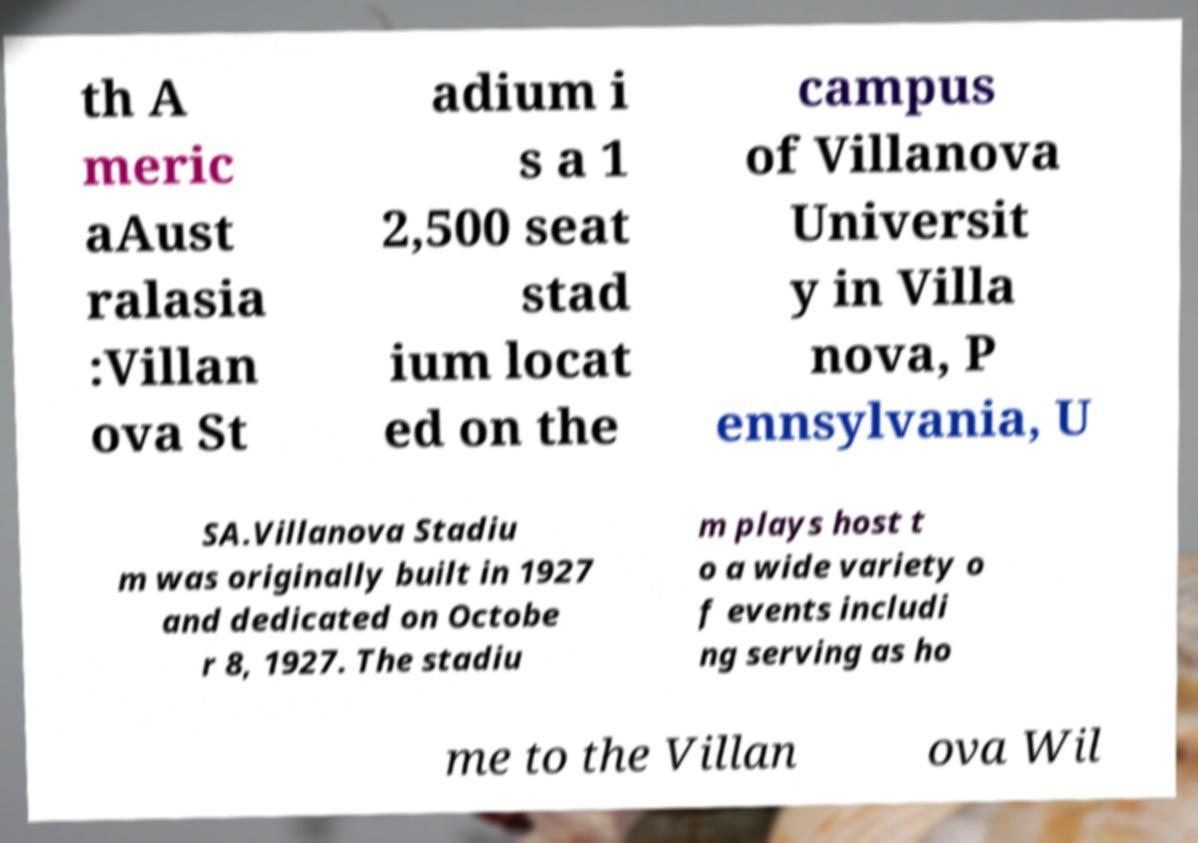Please read and relay the text visible in this image. What does it say? th A meric aAust ralasia :Villan ova St adium i s a 1 2,500 seat stad ium locat ed on the campus of Villanova Universit y in Villa nova, P ennsylvania, U SA.Villanova Stadiu m was originally built in 1927 and dedicated on Octobe r 8, 1927. The stadiu m plays host t o a wide variety o f events includi ng serving as ho me to the Villan ova Wil 